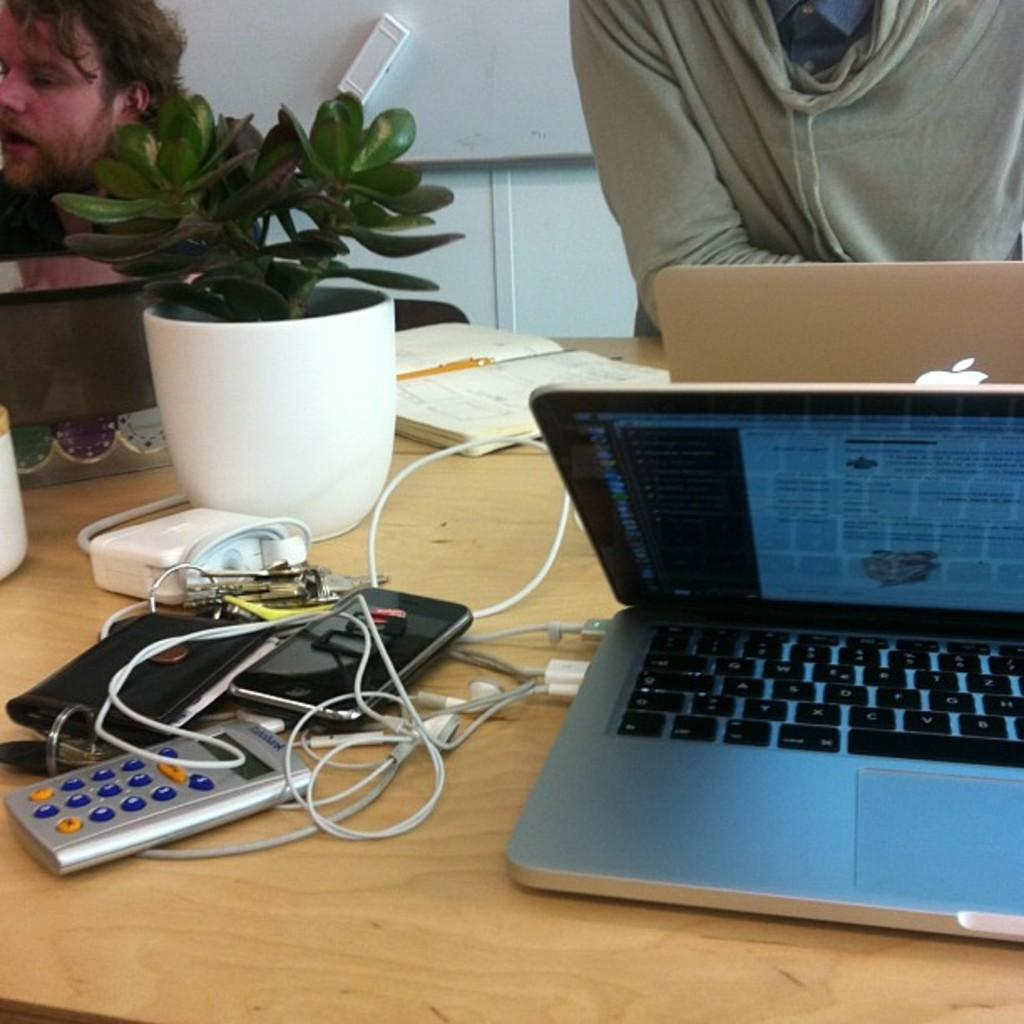How many people are in the image? There are two persons in the image. What is the location of the persons in the image? The persons are near a table. What can be seen on the table in the image? There is a houseplant, gadgets, a laptop, headsets, a pen, and a book on the table. What type of vase is present on the table in the image? There is no vase present on the table in the image. How many feet are visible in the image? The image does not show any feet; it only shows two persons near a table. 